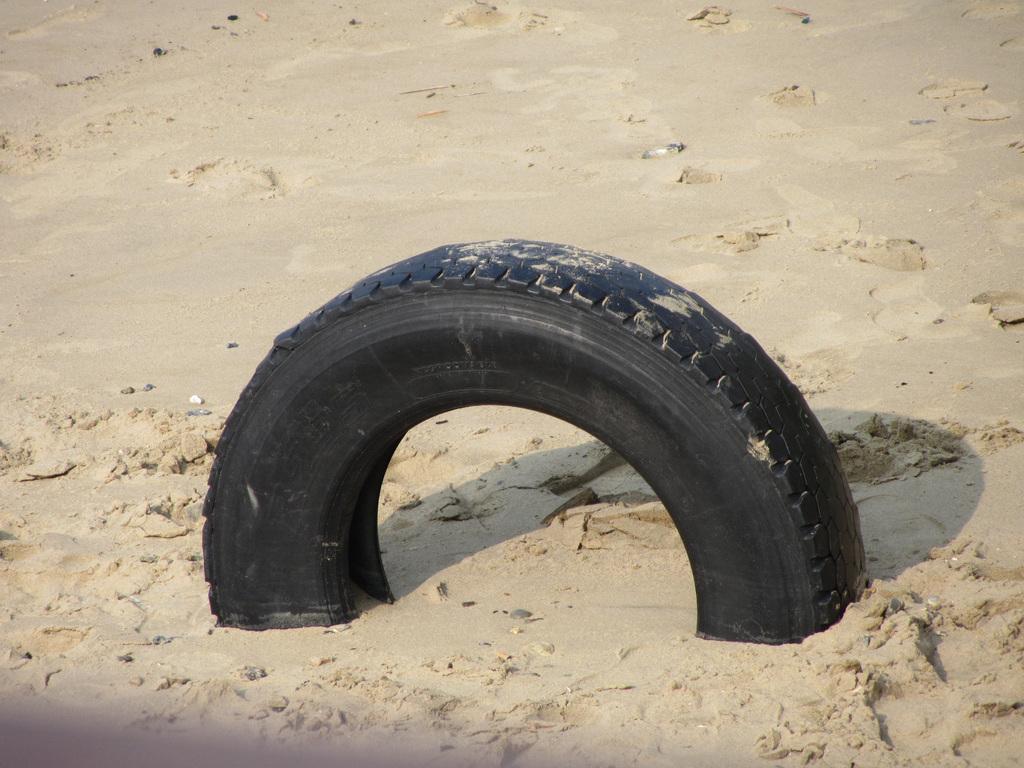In one or two sentences, can you explain what this image depicts? In this image I can see the black color tyre inside the sand and I can see few small stones. 